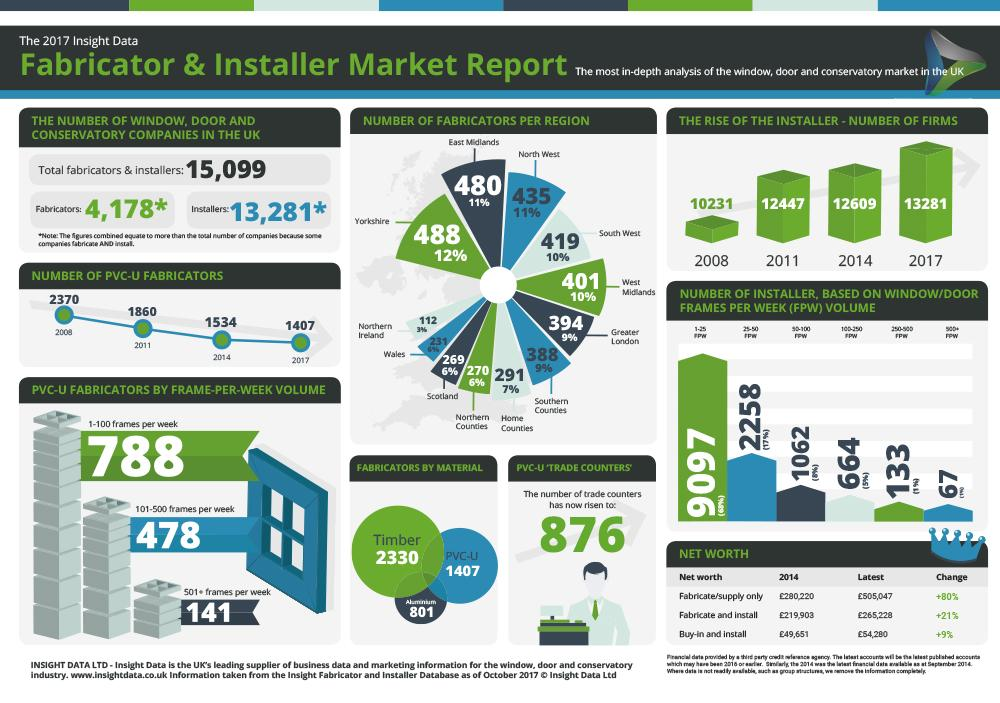Point out several critical features in this image. In the period from 2011 to 2017, the number of PVC-U fabricators decreased by 453. There are 915 fabricators located in the East Midlands and North West regions. There are 141 fabricators who work on more than 500 frames per week. It is evident that the region with the greatest number of fabricators is Yorkshire. The number of firms in the installer category increased by 3,050 from 2008 to 2017. 